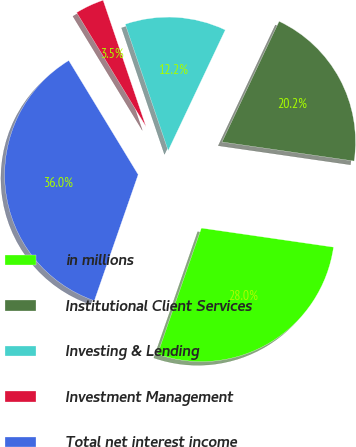<chart> <loc_0><loc_0><loc_500><loc_500><pie_chart><fcel>in millions<fcel>Institutional Client Services<fcel>Investing & Lending<fcel>Investment Management<fcel>Total net interest income<nl><fcel>28.04%<fcel>20.25%<fcel>12.24%<fcel>3.49%<fcel>35.98%<nl></chart> 